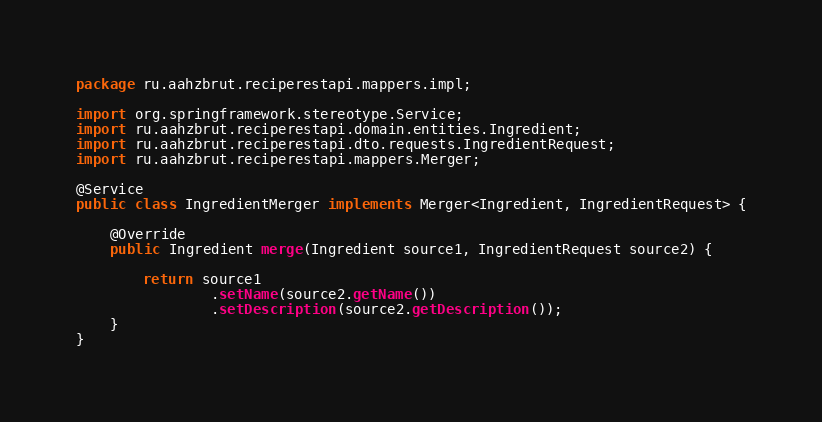Convert code to text. <code><loc_0><loc_0><loc_500><loc_500><_Java_>package ru.aahzbrut.reciperestapi.mappers.impl;

import org.springframework.stereotype.Service;
import ru.aahzbrut.reciperestapi.domain.entities.Ingredient;
import ru.aahzbrut.reciperestapi.dto.requests.IngredientRequest;
import ru.aahzbrut.reciperestapi.mappers.Merger;

@Service
public class IngredientMerger implements Merger<Ingredient, IngredientRequest> {

    @Override
    public Ingredient merge(Ingredient source1, IngredientRequest source2) {

        return source1
                .setName(source2.getName())
                .setDescription(source2.getDescription());
    }
}
</code> 